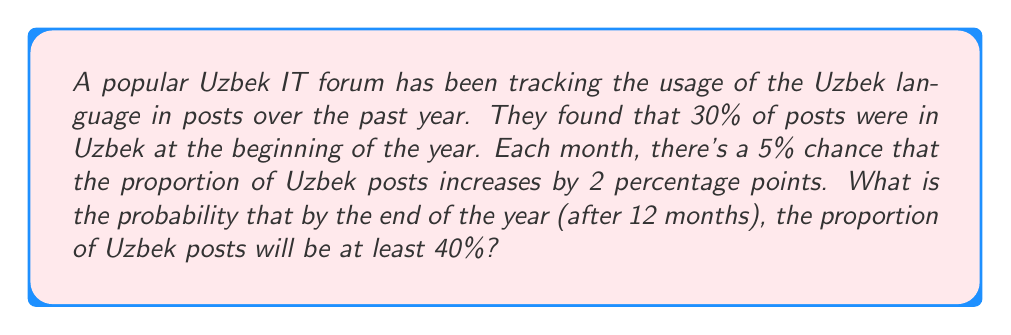Can you solve this math problem? Let's approach this step-by-step:

1) For the proportion to reach at least 40%, there need to be at least 5 increases of 2 percentage points each (30% + 5 * 2% = 40%).

2) We can model this as a binomial probability problem. We need to find the probability of at least 5 successes in 12 trials, where each trial has a 5% chance of success.

3) Let X be the number of successful increases. Then X follows a binomial distribution with n = 12 and p = 0.05.

4) We need to find P(X ≥ 5) = 1 - P(X < 5) = 1 - P(X ≤ 4)

5) Using the binomial probability formula:

   $$P(X = k) = \binom{n}{k} p^k (1-p)^{n-k}$$

6) We need to calculate:

   $$1 - [P(X = 0) + P(X = 1) + P(X = 2) + P(X = 3) + P(X = 4)]$$

7) Calculating each term:

   $$P(X = 0) = \binom{12}{0} 0.05^0 0.95^{12} = 0.5404$$
   $$P(X = 1) = \binom{12}{1} 0.05^1 0.95^{11} = 0.3413$$
   $$P(X = 2) = \binom{12}{2} 0.05^2 0.95^{10} = 0.0988$$
   $$P(X = 3) = \binom{12}{3} 0.05^3 0.95^9 = 0.0173$$
   $$P(X = 4) = \binom{12}{4} 0.05^4 0.95^8 = 0.0021$$

8) Sum these probabilities and subtract from 1:

   $$1 - (0.5404 + 0.3413 + 0.0988 + 0.0173 + 0.0021) = 0.0001$$

Therefore, the probability is approximately 0.0001 or 0.01%.
Answer: 0.0001 